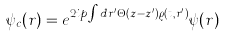Convert formula to latex. <formula><loc_0><loc_0><loc_500><loc_500>\psi _ { c } ( r ) = e ^ { 2 i p \int d r ^ { \prime } \Theta ( z - z ^ { \prime } ) \varrho ( t , r ^ { \prime } ) } \psi ( r )</formula> 